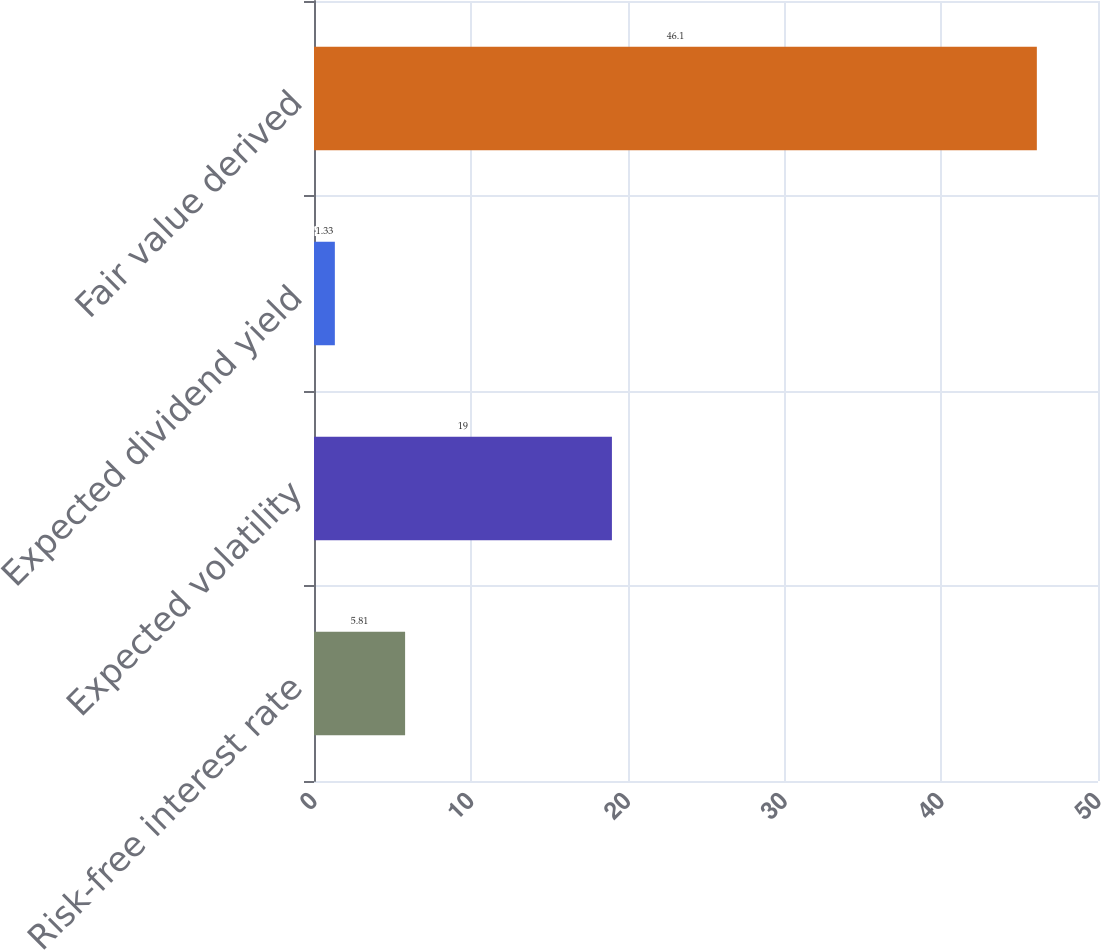Convert chart. <chart><loc_0><loc_0><loc_500><loc_500><bar_chart><fcel>Risk-free interest rate<fcel>Expected volatility<fcel>Expected dividend yield<fcel>Fair value derived<nl><fcel>5.81<fcel>19<fcel>1.33<fcel>46.1<nl></chart> 